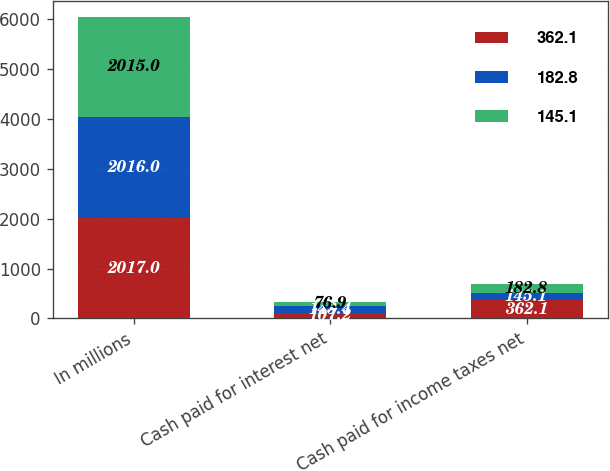Convert chart. <chart><loc_0><loc_0><loc_500><loc_500><stacked_bar_chart><ecel><fcel>In millions<fcel>Cash paid for interest net<fcel>Cash paid for income taxes net<nl><fcel>362.1<fcel>2017<fcel>107.2<fcel>362.1<nl><fcel>182.8<fcel>2016<fcel>143.4<fcel>145.1<nl><fcel>145.1<fcel>2015<fcel>76.9<fcel>182.8<nl></chart> 